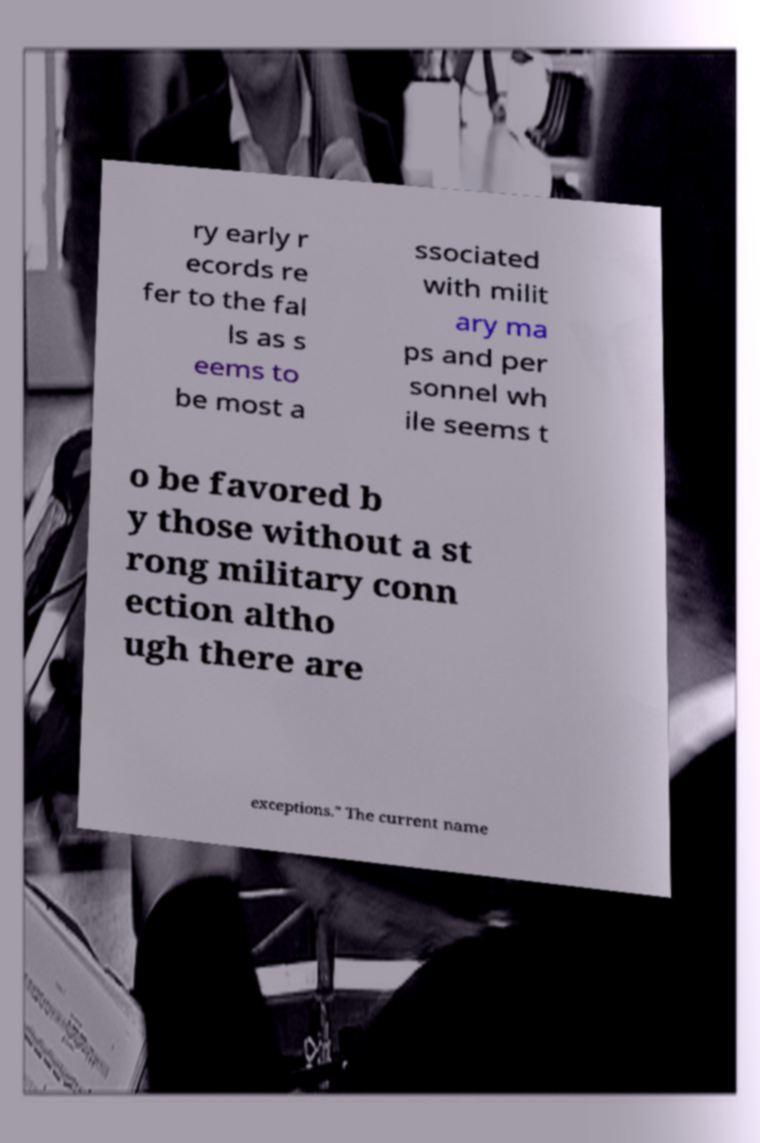Please read and relay the text visible in this image. What does it say? ry early r ecords re fer to the fal ls as s eems to be most a ssociated with milit ary ma ps and per sonnel wh ile seems t o be favored b y those without a st rong military conn ection altho ugh there are exceptions." The current name 